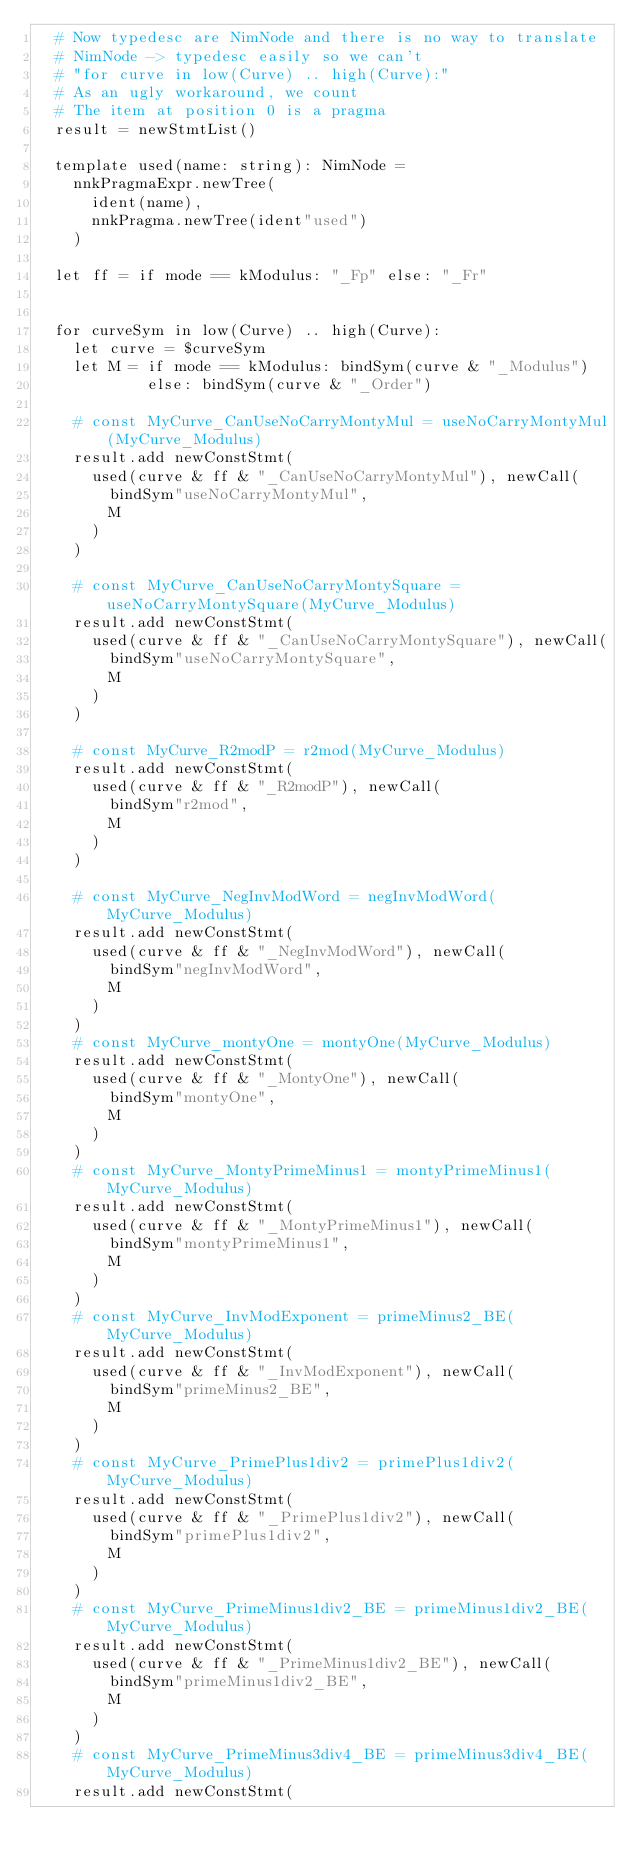Convert code to text. <code><loc_0><loc_0><loc_500><loc_500><_Nim_>  # Now typedesc are NimNode and there is no way to translate
  # NimNode -> typedesc easily so we can't
  # "for curve in low(Curve) .. high(Curve):"
  # As an ugly workaround, we count
  # The item at position 0 is a pragma
  result = newStmtList()

  template used(name: string): NimNode =
    nnkPragmaExpr.newTree(
      ident(name),
      nnkPragma.newTree(ident"used")
    )

  let ff = if mode == kModulus: "_Fp" else: "_Fr"


  for curveSym in low(Curve) .. high(Curve):
    let curve = $curveSym
    let M = if mode == kModulus: bindSym(curve & "_Modulus")
            else: bindSym(curve & "_Order")

    # const MyCurve_CanUseNoCarryMontyMul = useNoCarryMontyMul(MyCurve_Modulus)
    result.add newConstStmt(
      used(curve & ff & "_CanUseNoCarryMontyMul"), newCall(
        bindSym"useNoCarryMontyMul",
        M
      )
    )

    # const MyCurve_CanUseNoCarryMontySquare = useNoCarryMontySquare(MyCurve_Modulus)
    result.add newConstStmt(
      used(curve & ff & "_CanUseNoCarryMontySquare"), newCall(
        bindSym"useNoCarryMontySquare",
        M
      )
    )

    # const MyCurve_R2modP = r2mod(MyCurve_Modulus)
    result.add newConstStmt(
      used(curve & ff & "_R2modP"), newCall(
        bindSym"r2mod",
        M
      )
    )

    # const MyCurve_NegInvModWord = negInvModWord(MyCurve_Modulus)
    result.add newConstStmt(
      used(curve & ff & "_NegInvModWord"), newCall(
        bindSym"negInvModWord",
        M
      )
    )
    # const MyCurve_montyOne = montyOne(MyCurve_Modulus)
    result.add newConstStmt(
      used(curve & ff & "_MontyOne"), newCall(
        bindSym"montyOne",
        M
      )
    )
    # const MyCurve_MontyPrimeMinus1 = montyPrimeMinus1(MyCurve_Modulus)
    result.add newConstStmt(
      used(curve & ff & "_MontyPrimeMinus1"), newCall(
        bindSym"montyPrimeMinus1",
        M
      )
    )
    # const MyCurve_InvModExponent = primeMinus2_BE(MyCurve_Modulus)
    result.add newConstStmt(
      used(curve & ff & "_InvModExponent"), newCall(
        bindSym"primeMinus2_BE",
        M
      )
    )
    # const MyCurve_PrimePlus1div2 = primePlus1div2(MyCurve_Modulus)
    result.add newConstStmt(
      used(curve & ff & "_PrimePlus1div2"), newCall(
        bindSym"primePlus1div2",
        M
      )
    )
    # const MyCurve_PrimeMinus1div2_BE = primeMinus1div2_BE(MyCurve_Modulus)
    result.add newConstStmt(
      used(curve & ff & "_PrimeMinus1div2_BE"), newCall(
        bindSym"primeMinus1div2_BE",
        M
      )
    )
    # const MyCurve_PrimeMinus3div4_BE = primeMinus3div4_BE(MyCurve_Modulus)
    result.add newConstStmt(</code> 